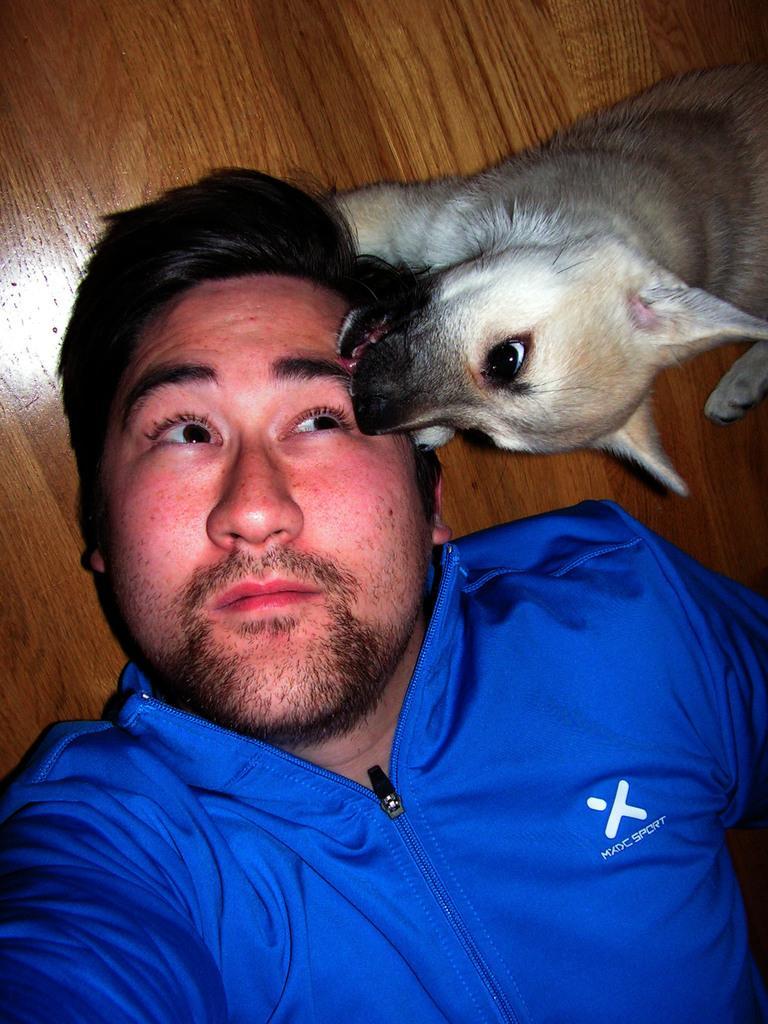In one or two sentences, can you explain what this image depicts? This is the man wearing blue shirt and laying on the floor. This is the dog. At background this looks like a wooden floor. 